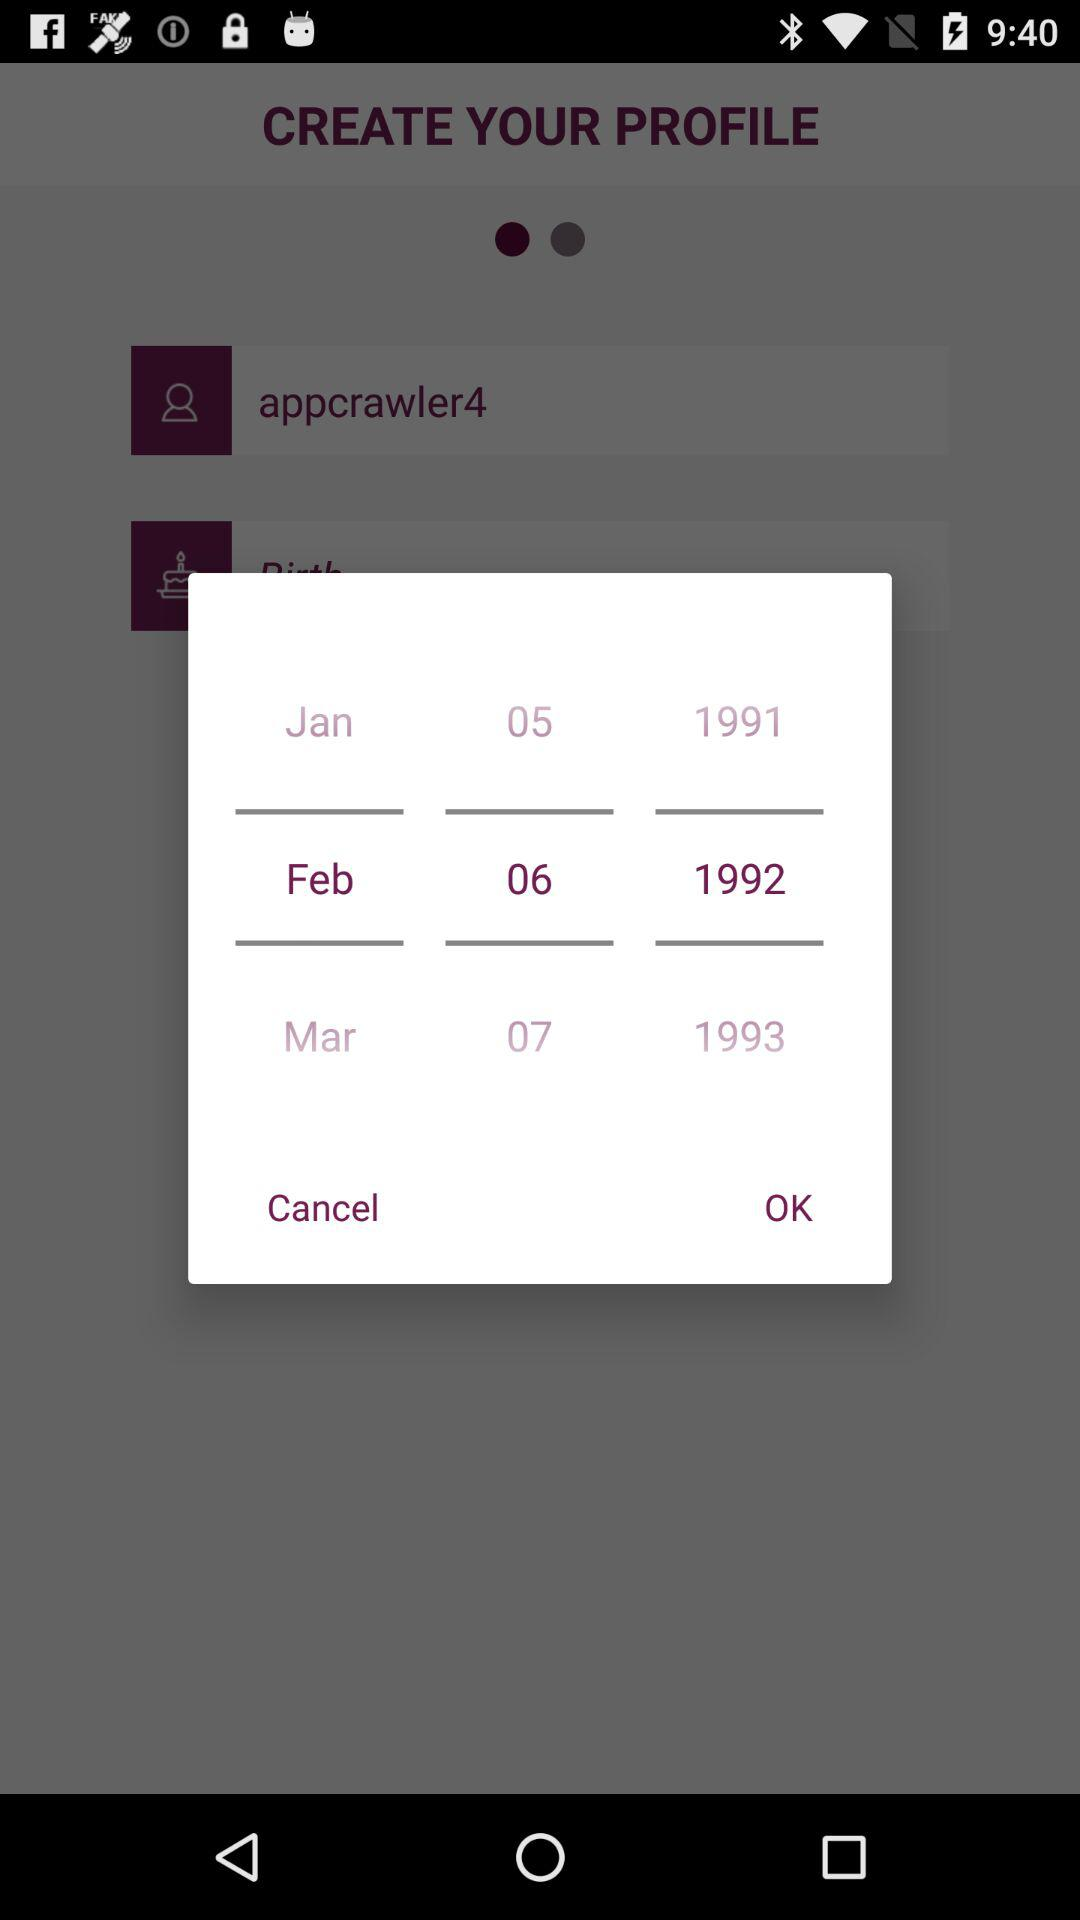What is the username? The username is "appcrawler4". 